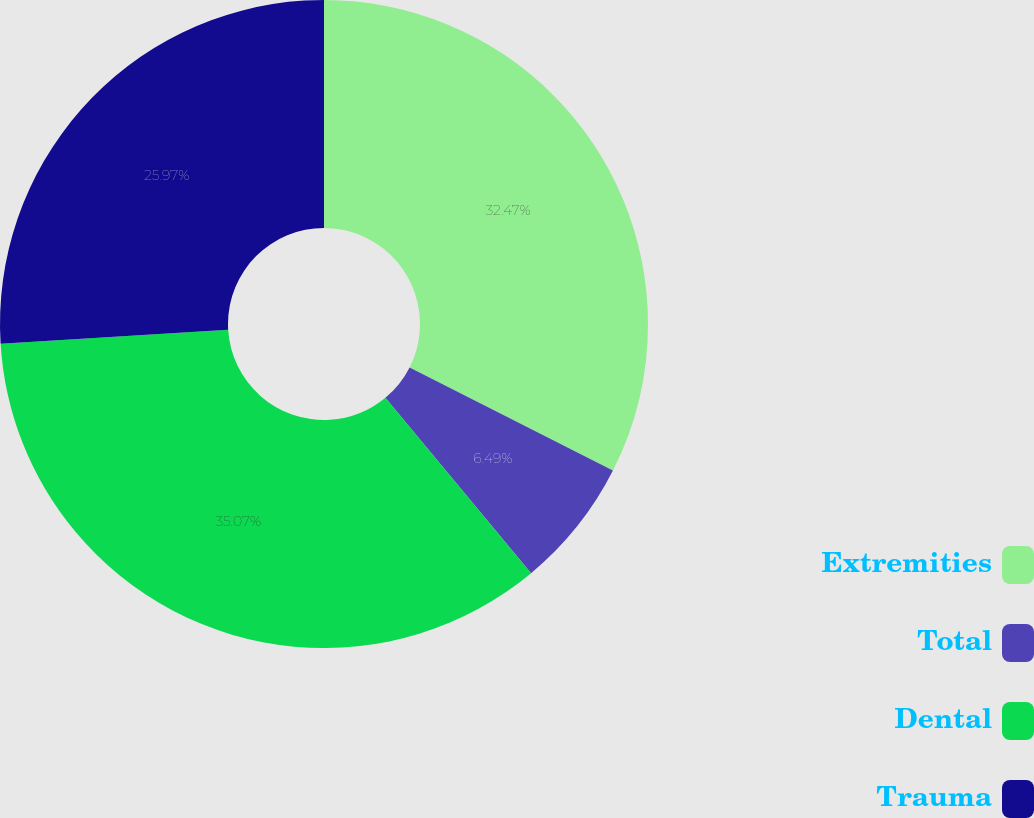Convert chart to OTSL. <chart><loc_0><loc_0><loc_500><loc_500><pie_chart><fcel>Extremities<fcel>Total<fcel>Dental<fcel>Trauma<nl><fcel>32.47%<fcel>6.49%<fcel>35.06%<fcel>25.97%<nl></chart> 